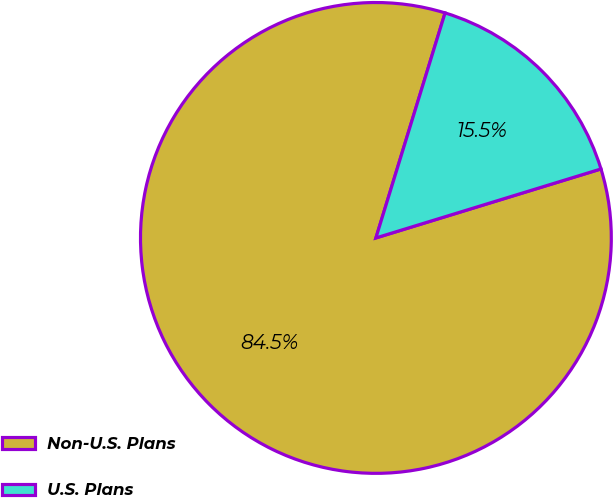Convert chart to OTSL. <chart><loc_0><loc_0><loc_500><loc_500><pie_chart><fcel>Non-U.S. Plans<fcel>U.S. Plans<nl><fcel>84.48%<fcel>15.52%<nl></chart> 